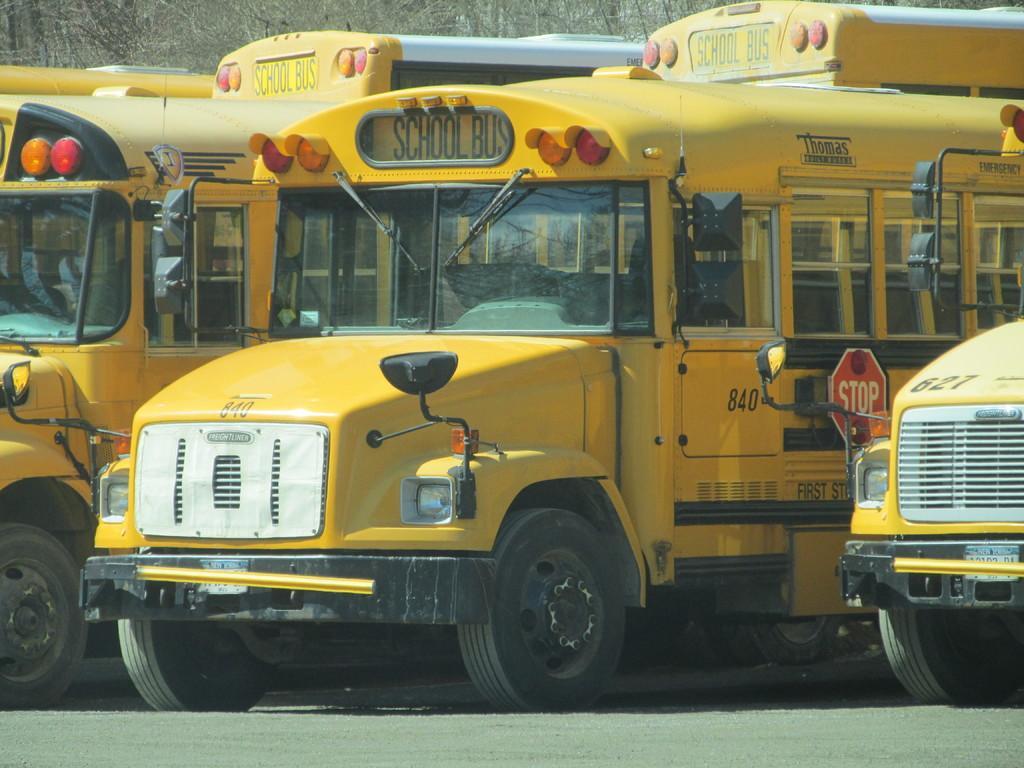Could you give a brief overview of what you see in this image? In this image we can see three school buses which are yellow in color. 